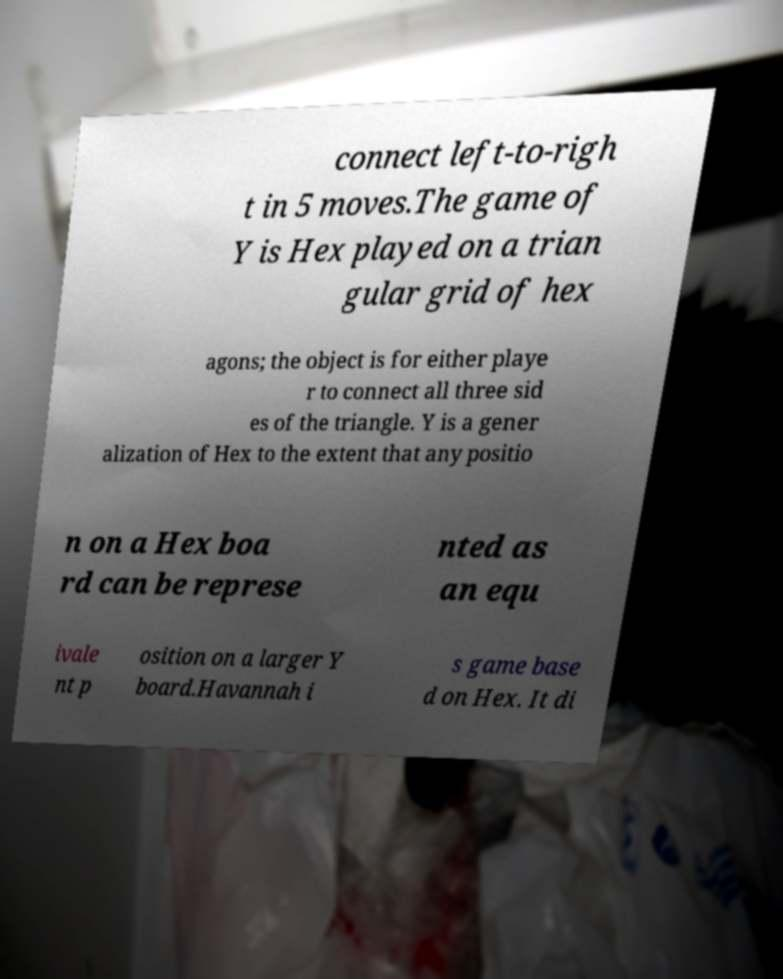There's text embedded in this image that I need extracted. Can you transcribe it verbatim? connect left-to-righ t in 5 moves.The game of Y is Hex played on a trian gular grid of hex agons; the object is for either playe r to connect all three sid es of the triangle. Y is a gener alization of Hex to the extent that any positio n on a Hex boa rd can be represe nted as an equ ivale nt p osition on a larger Y board.Havannah i s game base d on Hex. It di 